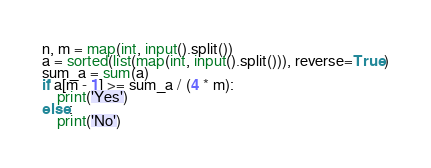<code> <loc_0><loc_0><loc_500><loc_500><_Python_>n, m = map(int, input().split())
a = sorted(list(map(int, input().split())), reverse=True)
sum_a = sum(a)
if a[m - 1] >= sum_a / (4 * m):
    print('Yes')
else:
    print('No')</code> 